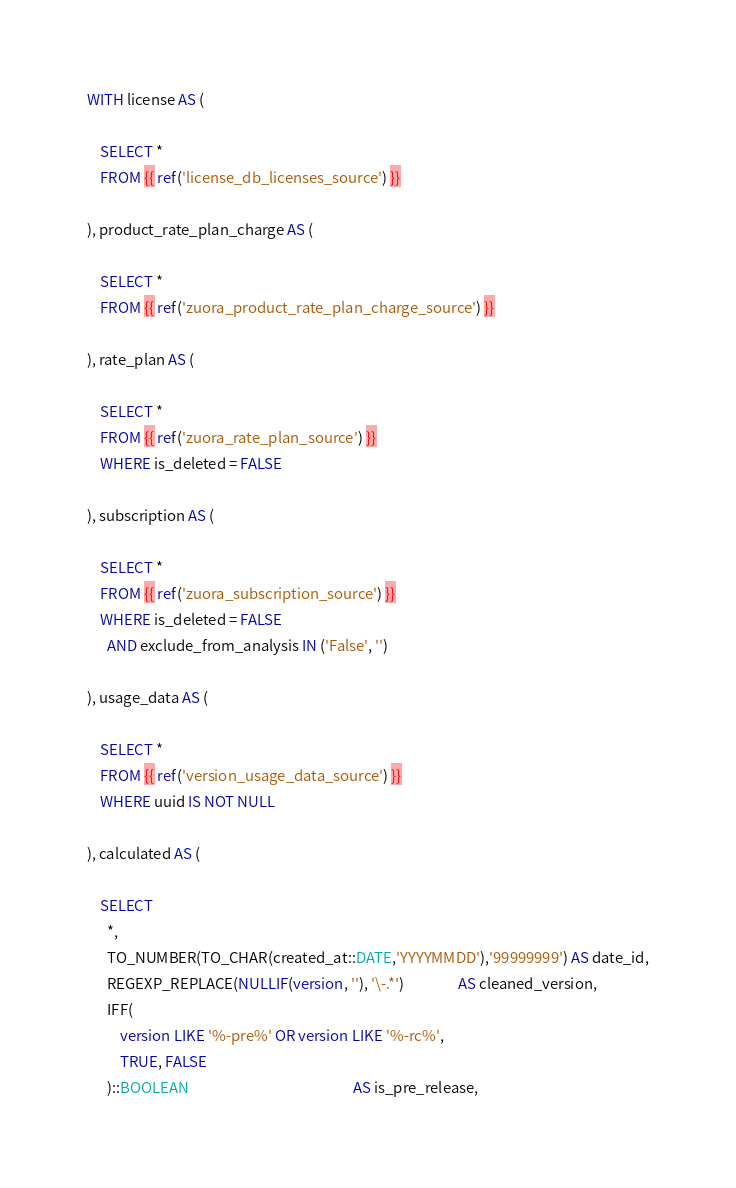Convert code to text. <code><loc_0><loc_0><loc_500><loc_500><_SQL_>WITH license AS (

    SELECT *
    FROM {{ ref('license_db_licenses_source') }}

), product_rate_plan_charge AS (

    SELECT *
    FROM {{ ref('zuora_product_rate_plan_charge_source') }}

), rate_plan AS (

    SELECT *
    FROM {{ ref('zuora_rate_plan_source') }}
    WHERE is_deleted = FALSE

), subscription AS (

    SELECT *
    FROM {{ ref('zuora_subscription_source') }}
    WHERE is_deleted = FALSE
      AND exclude_from_analysis IN ('False', '')

), usage_data AS (

    SELECT *
    FROM {{ ref('version_usage_data_source') }}
    WHERE uuid IS NOT NULL

), calculated AS (

    SELECT
      *,
      TO_NUMBER(TO_CHAR(created_at::DATE,'YYYYMMDD'),'99999999') AS date_id,
      REGEXP_REPLACE(NULLIF(version, ''), '\-.*')                AS cleaned_version,
      IFF(
          version LIKE '%-pre%' OR version LIKE '%-rc%', 
          TRUE, FALSE
      )::BOOLEAN                                                 AS is_pre_release,</code> 